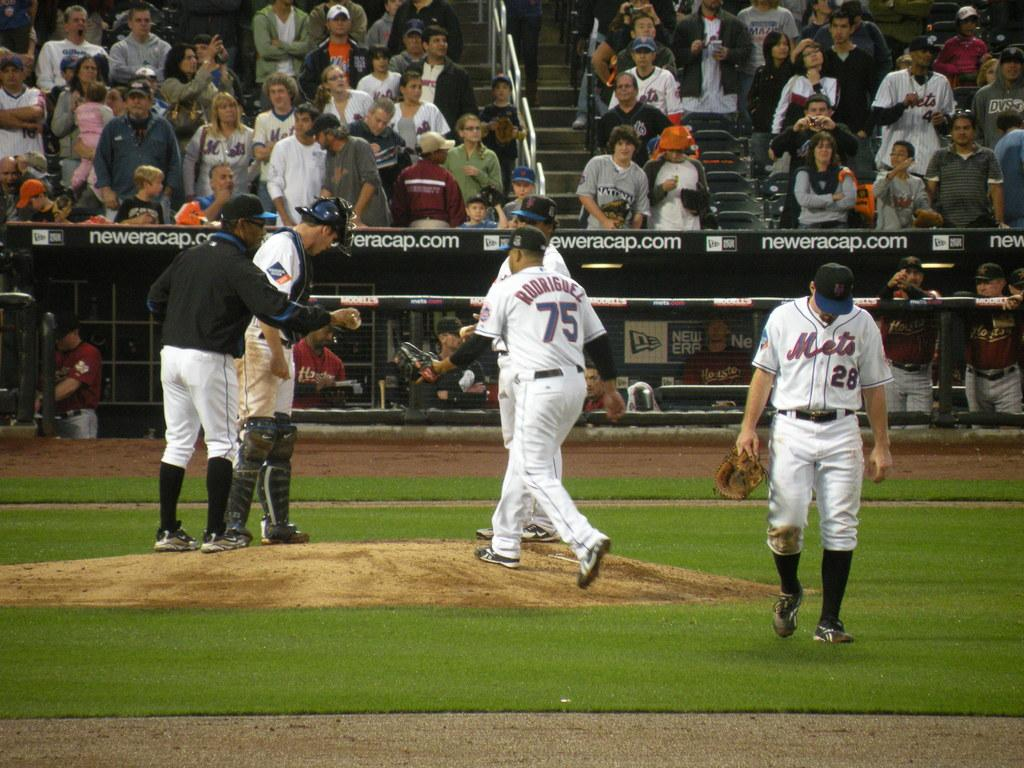<image>
Offer a succinct explanation of the picture presented. a pitcher on the Mets with Rodriguez on their back 